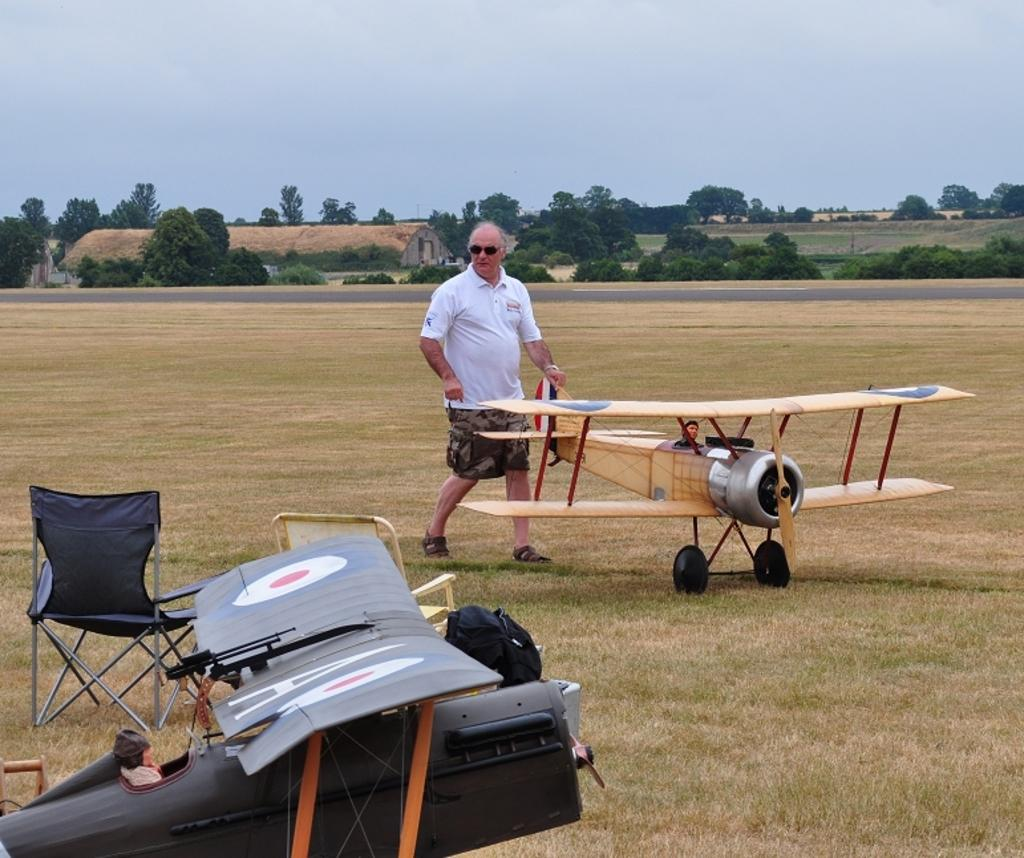What can be seen in the background of the image? There is a sky in the image. What type of natural elements are present in the image? There are trees in the image. What type of vehicles are in the image? There are jet planes in the image. What type of furniture is in the image? There is a chair in the image. Who is present in the image? There is a man standing in the image. Can you tell me where the river is located in the image? There is no river present in the image. What type of cup is being used by the man in the image? There is no cup present in the image. 